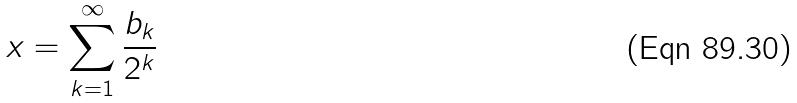Convert formula to latex. <formula><loc_0><loc_0><loc_500><loc_500>x = \sum _ { k = 1 } ^ { \infty } \frac { b _ { k } } { 2 ^ { k } }</formula> 